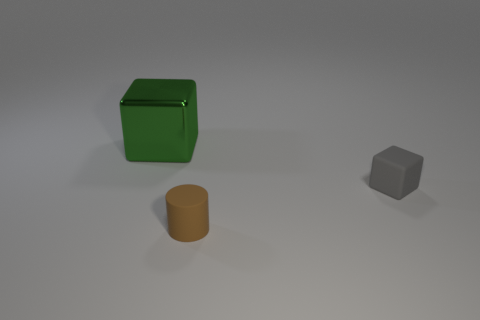Add 2 green metallic things. How many objects exist? 5 Subtract all cylinders. How many objects are left? 2 Add 1 small brown cylinders. How many small brown cylinders exist? 2 Subtract 0 red cylinders. How many objects are left? 3 Subtract all small brown rubber cylinders. Subtract all small brown rubber cylinders. How many objects are left? 1 Add 2 large green metal objects. How many large green metal objects are left? 3 